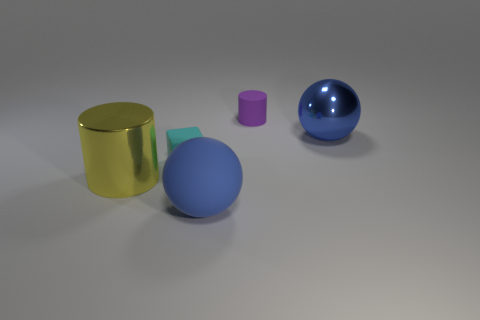What size is the other sphere that is the same color as the big metallic ball?
Provide a succinct answer. Large. What shape is the blue object that is left of the large blue thing that is right of the blue thing that is on the left side of the purple object?
Provide a succinct answer. Sphere. How many other things are there of the same material as the small cyan block?
Give a very brief answer. 2. Does the big blue ball on the left side of the small purple matte cylinder have the same material as the small object behind the small cyan matte block?
Offer a very short reply. Yes. How many tiny matte things are both in front of the small purple thing and behind the small cyan cube?
Keep it short and to the point. 0. Is there a big shiny object that has the same shape as the small purple matte thing?
Your answer should be compact. Yes. There is a purple matte thing that is the same size as the block; what shape is it?
Provide a short and direct response. Cylinder. Is the number of small purple matte cylinders behind the large matte thing the same as the number of metallic things that are to the right of the big yellow shiny thing?
Make the answer very short. Yes. How big is the purple thing behind the big blue sphere that is behind the large yellow thing?
Give a very brief answer. Small. Are there any purple objects that have the same size as the cyan cube?
Provide a short and direct response. Yes. 